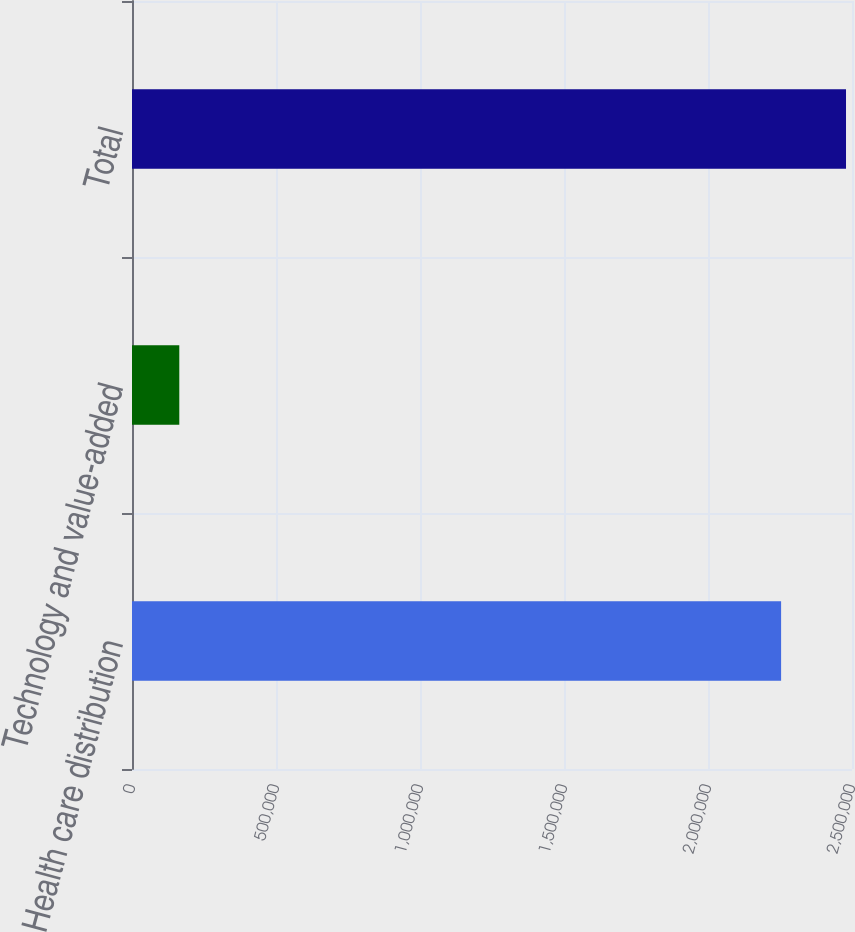<chart> <loc_0><loc_0><loc_500><loc_500><bar_chart><fcel>Health care distribution<fcel>Technology and value-added<fcel>Total<nl><fcel>2.25381e+06<fcel>164241<fcel>2.4792e+06<nl></chart> 